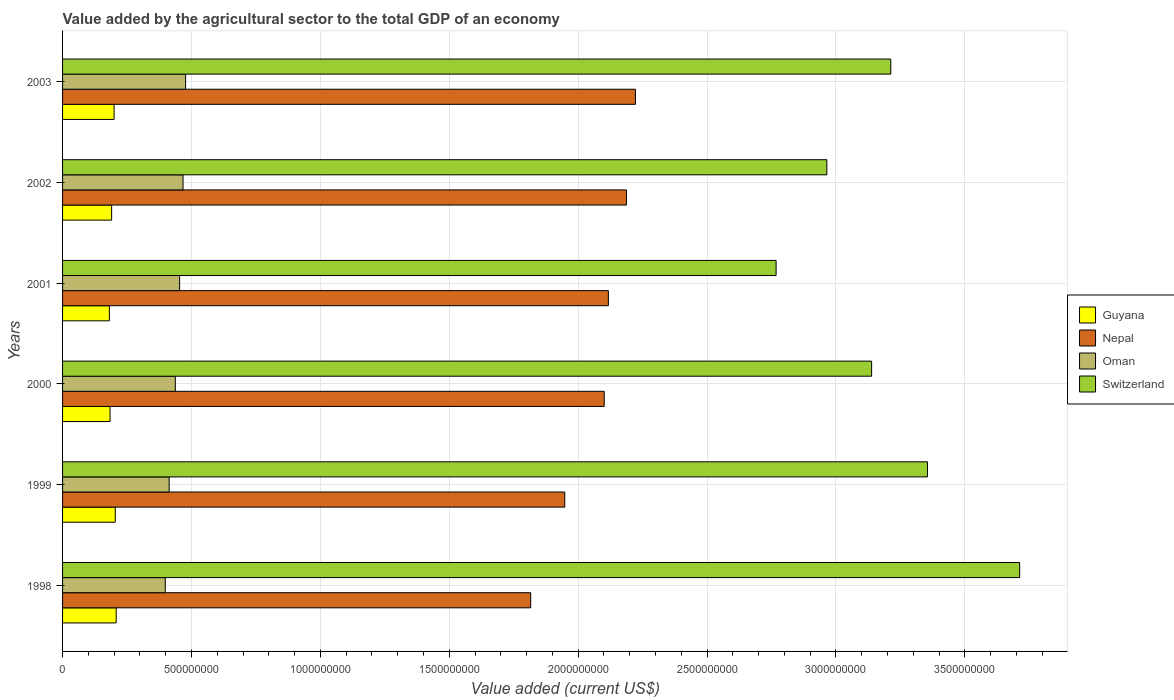How many groups of bars are there?
Keep it short and to the point. 6. Are the number of bars per tick equal to the number of legend labels?
Offer a terse response. Yes. How many bars are there on the 5th tick from the bottom?
Provide a short and direct response. 4. What is the label of the 3rd group of bars from the top?
Ensure brevity in your answer.  2001. In how many cases, is the number of bars for a given year not equal to the number of legend labels?
Provide a short and direct response. 0. What is the value added by the agricultural sector to the total GDP in Oman in 2003?
Your answer should be compact. 4.77e+08. Across all years, what is the maximum value added by the agricultural sector to the total GDP in Guyana?
Provide a short and direct response. 2.08e+08. Across all years, what is the minimum value added by the agricultural sector to the total GDP in Nepal?
Your response must be concise. 1.82e+09. In which year was the value added by the agricultural sector to the total GDP in Nepal maximum?
Your answer should be compact. 2003. In which year was the value added by the agricultural sector to the total GDP in Nepal minimum?
Offer a very short reply. 1998. What is the total value added by the agricultural sector to the total GDP in Nepal in the graph?
Provide a short and direct response. 1.24e+1. What is the difference between the value added by the agricultural sector to the total GDP in Guyana in 1998 and that in 2003?
Your response must be concise. 8.14e+06. What is the difference between the value added by the agricultural sector to the total GDP in Guyana in 2000 and the value added by the agricultural sector to the total GDP in Oman in 1998?
Your answer should be compact. -2.14e+08. What is the average value added by the agricultural sector to the total GDP in Oman per year?
Ensure brevity in your answer.  4.41e+08. In the year 2001, what is the difference between the value added by the agricultural sector to the total GDP in Guyana and value added by the agricultural sector to the total GDP in Switzerland?
Provide a succinct answer. -2.59e+09. In how many years, is the value added by the agricultural sector to the total GDP in Guyana greater than 500000000 US$?
Ensure brevity in your answer.  0. What is the ratio of the value added by the agricultural sector to the total GDP in Oman in 1998 to that in 2002?
Offer a very short reply. 0.85. Is the value added by the agricultural sector to the total GDP in Nepal in 1999 less than that in 2000?
Offer a terse response. Yes. Is the difference between the value added by the agricultural sector to the total GDP in Guyana in 1998 and 2000 greater than the difference between the value added by the agricultural sector to the total GDP in Switzerland in 1998 and 2000?
Your answer should be compact. No. What is the difference between the highest and the second highest value added by the agricultural sector to the total GDP in Guyana?
Offer a terse response. 3.48e+06. What is the difference between the highest and the lowest value added by the agricultural sector to the total GDP in Guyana?
Offer a very short reply. 2.65e+07. In how many years, is the value added by the agricultural sector to the total GDP in Oman greater than the average value added by the agricultural sector to the total GDP in Oman taken over all years?
Your response must be concise. 3. What does the 2nd bar from the top in 2001 represents?
Offer a very short reply. Oman. What does the 1st bar from the bottom in 1999 represents?
Give a very brief answer. Guyana. Is it the case that in every year, the sum of the value added by the agricultural sector to the total GDP in Nepal and value added by the agricultural sector to the total GDP in Guyana is greater than the value added by the agricultural sector to the total GDP in Switzerland?
Give a very brief answer. No. Are all the bars in the graph horizontal?
Your answer should be very brief. Yes. Are the values on the major ticks of X-axis written in scientific E-notation?
Your answer should be compact. No. How are the legend labels stacked?
Your answer should be compact. Vertical. What is the title of the graph?
Your response must be concise. Value added by the agricultural sector to the total GDP of an economy. Does "Sub-Saharan Africa (all income levels)" appear as one of the legend labels in the graph?
Make the answer very short. No. What is the label or title of the X-axis?
Make the answer very short. Value added (current US$). What is the label or title of the Y-axis?
Provide a succinct answer. Years. What is the Value added (current US$) of Guyana in 1998?
Make the answer very short. 2.08e+08. What is the Value added (current US$) of Nepal in 1998?
Your answer should be compact. 1.82e+09. What is the Value added (current US$) of Oman in 1998?
Your answer should be very brief. 3.98e+08. What is the Value added (current US$) in Switzerland in 1998?
Your answer should be compact. 3.71e+09. What is the Value added (current US$) of Guyana in 1999?
Provide a short and direct response. 2.05e+08. What is the Value added (current US$) in Nepal in 1999?
Your answer should be very brief. 1.95e+09. What is the Value added (current US$) of Oman in 1999?
Your answer should be very brief. 4.14e+08. What is the Value added (current US$) of Switzerland in 1999?
Provide a short and direct response. 3.36e+09. What is the Value added (current US$) in Guyana in 2000?
Your answer should be compact. 1.84e+08. What is the Value added (current US$) in Nepal in 2000?
Provide a succinct answer. 2.10e+09. What is the Value added (current US$) in Oman in 2000?
Ensure brevity in your answer.  4.37e+08. What is the Value added (current US$) in Switzerland in 2000?
Offer a very short reply. 3.14e+09. What is the Value added (current US$) of Guyana in 2001?
Make the answer very short. 1.82e+08. What is the Value added (current US$) of Nepal in 2001?
Your answer should be compact. 2.12e+09. What is the Value added (current US$) in Oman in 2001?
Offer a terse response. 4.54e+08. What is the Value added (current US$) in Switzerland in 2001?
Ensure brevity in your answer.  2.77e+09. What is the Value added (current US$) of Guyana in 2002?
Offer a very short reply. 1.90e+08. What is the Value added (current US$) in Nepal in 2002?
Give a very brief answer. 2.19e+09. What is the Value added (current US$) of Oman in 2002?
Provide a short and direct response. 4.67e+08. What is the Value added (current US$) of Switzerland in 2002?
Give a very brief answer. 2.96e+09. What is the Value added (current US$) of Guyana in 2003?
Make the answer very short. 2.00e+08. What is the Value added (current US$) in Nepal in 2003?
Offer a terse response. 2.22e+09. What is the Value added (current US$) of Oman in 2003?
Make the answer very short. 4.77e+08. What is the Value added (current US$) in Switzerland in 2003?
Provide a succinct answer. 3.21e+09. Across all years, what is the maximum Value added (current US$) in Guyana?
Provide a succinct answer. 2.08e+08. Across all years, what is the maximum Value added (current US$) in Nepal?
Make the answer very short. 2.22e+09. Across all years, what is the maximum Value added (current US$) in Oman?
Your answer should be very brief. 4.77e+08. Across all years, what is the maximum Value added (current US$) of Switzerland?
Keep it short and to the point. 3.71e+09. Across all years, what is the minimum Value added (current US$) of Guyana?
Ensure brevity in your answer.  1.82e+08. Across all years, what is the minimum Value added (current US$) in Nepal?
Provide a succinct answer. 1.82e+09. Across all years, what is the minimum Value added (current US$) of Oman?
Make the answer very short. 3.98e+08. Across all years, what is the minimum Value added (current US$) in Switzerland?
Provide a short and direct response. 2.77e+09. What is the total Value added (current US$) in Guyana in the graph?
Your answer should be very brief. 1.17e+09. What is the total Value added (current US$) of Nepal in the graph?
Your answer should be very brief. 1.24e+1. What is the total Value added (current US$) of Oman in the graph?
Offer a terse response. 2.65e+09. What is the total Value added (current US$) in Switzerland in the graph?
Your answer should be very brief. 1.92e+1. What is the difference between the Value added (current US$) in Guyana in 1998 and that in 1999?
Your response must be concise. 3.48e+06. What is the difference between the Value added (current US$) in Nepal in 1998 and that in 1999?
Give a very brief answer. -1.32e+08. What is the difference between the Value added (current US$) in Oman in 1998 and that in 1999?
Give a very brief answer. -1.51e+07. What is the difference between the Value added (current US$) in Switzerland in 1998 and that in 1999?
Provide a short and direct response. 3.58e+08. What is the difference between the Value added (current US$) in Guyana in 1998 and that in 2000?
Provide a succinct answer. 2.38e+07. What is the difference between the Value added (current US$) of Nepal in 1998 and that in 2000?
Your answer should be very brief. -2.85e+08. What is the difference between the Value added (current US$) of Oman in 1998 and that in 2000?
Give a very brief answer. -3.90e+07. What is the difference between the Value added (current US$) of Switzerland in 1998 and that in 2000?
Give a very brief answer. 5.74e+08. What is the difference between the Value added (current US$) of Guyana in 1998 and that in 2001?
Offer a very short reply. 2.65e+07. What is the difference between the Value added (current US$) in Nepal in 1998 and that in 2001?
Make the answer very short. -3.01e+08. What is the difference between the Value added (current US$) of Oman in 1998 and that in 2001?
Provide a succinct answer. -5.57e+07. What is the difference between the Value added (current US$) of Switzerland in 1998 and that in 2001?
Give a very brief answer. 9.45e+08. What is the difference between the Value added (current US$) of Guyana in 1998 and that in 2002?
Your response must be concise. 1.76e+07. What is the difference between the Value added (current US$) in Nepal in 1998 and that in 2002?
Make the answer very short. -3.72e+08. What is the difference between the Value added (current US$) of Oman in 1998 and that in 2002?
Your answer should be compact. -6.89e+07. What is the difference between the Value added (current US$) in Switzerland in 1998 and that in 2002?
Your answer should be very brief. 7.48e+08. What is the difference between the Value added (current US$) in Guyana in 1998 and that in 2003?
Keep it short and to the point. 8.14e+06. What is the difference between the Value added (current US$) in Nepal in 1998 and that in 2003?
Your answer should be compact. -4.06e+08. What is the difference between the Value added (current US$) in Oman in 1998 and that in 2003?
Keep it short and to the point. -7.88e+07. What is the difference between the Value added (current US$) of Switzerland in 1998 and that in 2003?
Your answer should be compact. 5.00e+08. What is the difference between the Value added (current US$) of Guyana in 1999 and that in 2000?
Provide a succinct answer. 2.03e+07. What is the difference between the Value added (current US$) of Nepal in 1999 and that in 2000?
Your answer should be compact. -1.53e+08. What is the difference between the Value added (current US$) in Oman in 1999 and that in 2000?
Your answer should be compact. -2.39e+07. What is the difference between the Value added (current US$) in Switzerland in 1999 and that in 2000?
Your answer should be compact. 2.17e+08. What is the difference between the Value added (current US$) in Guyana in 1999 and that in 2001?
Your answer should be compact. 2.30e+07. What is the difference between the Value added (current US$) of Nepal in 1999 and that in 2001?
Offer a very short reply. -1.69e+08. What is the difference between the Value added (current US$) in Oman in 1999 and that in 2001?
Your answer should be compact. -4.06e+07. What is the difference between the Value added (current US$) of Switzerland in 1999 and that in 2001?
Your answer should be compact. 5.87e+08. What is the difference between the Value added (current US$) of Guyana in 1999 and that in 2002?
Provide a succinct answer. 1.41e+07. What is the difference between the Value added (current US$) in Nepal in 1999 and that in 2002?
Your answer should be compact. -2.39e+08. What is the difference between the Value added (current US$) of Oman in 1999 and that in 2002?
Provide a short and direct response. -5.38e+07. What is the difference between the Value added (current US$) of Switzerland in 1999 and that in 2002?
Offer a very short reply. 3.90e+08. What is the difference between the Value added (current US$) of Guyana in 1999 and that in 2003?
Provide a succinct answer. 4.66e+06. What is the difference between the Value added (current US$) in Nepal in 1999 and that in 2003?
Provide a succinct answer. -2.74e+08. What is the difference between the Value added (current US$) of Oman in 1999 and that in 2003?
Provide a short and direct response. -6.37e+07. What is the difference between the Value added (current US$) in Switzerland in 1999 and that in 2003?
Your answer should be very brief. 1.42e+08. What is the difference between the Value added (current US$) of Guyana in 2000 and that in 2001?
Your response must be concise. 2.65e+06. What is the difference between the Value added (current US$) of Nepal in 2000 and that in 2001?
Give a very brief answer. -1.61e+07. What is the difference between the Value added (current US$) in Oman in 2000 and that in 2001?
Provide a short and direct response. -1.66e+07. What is the difference between the Value added (current US$) of Switzerland in 2000 and that in 2001?
Offer a very short reply. 3.71e+08. What is the difference between the Value added (current US$) of Guyana in 2000 and that in 2002?
Make the answer very short. -6.18e+06. What is the difference between the Value added (current US$) in Nepal in 2000 and that in 2002?
Give a very brief answer. -8.62e+07. What is the difference between the Value added (current US$) of Oman in 2000 and that in 2002?
Make the answer very short. -2.99e+07. What is the difference between the Value added (current US$) of Switzerland in 2000 and that in 2002?
Provide a succinct answer. 1.74e+08. What is the difference between the Value added (current US$) of Guyana in 2000 and that in 2003?
Offer a very short reply. -1.57e+07. What is the difference between the Value added (current US$) of Nepal in 2000 and that in 2003?
Give a very brief answer. -1.21e+08. What is the difference between the Value added (current US$) of Oman in 2000 and that in 2003?
Keep it short and to the point. -3.98e+07. What is the difference between the Value added (current US$) in Switzerland in 2000 and that in 2003?
Your response must be concise. -7.43e+07. What is the difference between the Value added (current US$) in Guyana in 2001 and that in 2002?
Your answer should be very brief. -8.84e+06. What is the difference between the Value added (current US$) in Nepal in 2001 and that in 2002?
Your answer should be compact. -7.01e+07. What is the difference between the Value added (current US$) in Oman in 2001 and that in 2002?
Your response must be concise. -1.33e+07. What is the difference between the Value added (current US$) in Switzerland in 2001 and that in 2002?
Make the answer very short. -1.97e+08. What is the difference between the Value added (current US$) of Guyana in 2001 and that in 2003?
Your answer should be compact. -1.83e+07. What is the difference between the Value added (current US$) of Nepal in 2001 and that in 2003?
Give a very brief answer. -1.05e+08. What is the difference between the Value added (current US$) in Oman in 2001 and that in 2003?
Provide a short and direct response. -2.31e+07. What is the difference between the Value added (current US$) of Switzerland in 2001 and that in 2003?
Provide a succinct answer. -4.45e+08. What is the difference between the Value added (current US$) of Guyana in 2002 and that in 2003?
Provide a succinct answer. -9.49e+06. What is the difference between the Value added (current US$) of Nepal in 2002 and that in 2003?
Your answer should be compact. -3.50e+07. What is the difference between the Value added (current US$) in Oman in 2002 and that in 2003?
Ensure brevity in your answer.  -9.88e+06. What is the difference between the Value added (current US$) in Switzerland in 2002 and that in 2003?
Offer a terse response. -2.48e+08. What is the difference between the Value added (current US$) in Guyana in 1998 and the Value added (current US$) in Nepal in 1999?
Your answer should be compact. -1.74e+09. What is the difference between the Value added (current US$) of Guyana in 1998 and the Value added (current US$) of Oman in 1999?
Keep it short and to the point. -2.06e+08. What is the difference between the Value added (current US$) in Guyana in 1998 and the Value added (current US$) in Switzerland in 1999?
Make the answer very short. -3.15e+09. What is the difference between the Value added (current US$) of Nepal in 1998 and the Value added (current US$) of Oman in 1999?
Ensure brevity in your answer.  1.40e+09. What is the difference between the Value added (current US$) in Nepal in 1998 and the Value added (current US$) in Switzerland in 1999?
Offer a very short reply. -1.54e+09. What is the difference between the Value added (current US$) of Oman in 1998 and the Value added (current US$) of Switzerland in 1999?
Provide a short and direct response. -2.96e+09. What is the difference between the Value added (current US$) in Guyana in 1998 and the Value added (current US$) in Nepal in 2000?
Give a very brief answer. -1.89e+09. What is the difference between the Value added (current US$) in Guyana in 1998 and the Value added (current US$) in Oman in 2000?
Provide a succinct answer. -2.29e+08. What is the difference between the Value added (current US$) of Guyana in 1998 and the Value added (current US$) of Switzerland in 2000?
Keep it short and to the point. -2.93e+09. What is the difference between the Value added (current US$) in Nepal in 1998 and the Value added (current US$) in Oman in 2000?
Keep it short and to the point. 1.38e+09. What is the difference between the Value added (current US$) in Nepal in 1998 and the Value added (current US$) in Switzerland in 2000?
Give a very brief answer. -1.32e+09. What is the difference between the Value added (current US$) in Oman in 1998 and the Value added (current US$) in Switzerland in 2000?
Give a very brief answer. -2.74e+09. What is the difference between the Value added (current US$) in Guyana in 1998 and the Value added (current US$) in Nepal in 2001?
Your response must be concise. -1.91e+09. What is the difference between the Value added (current US$) of Guyana in 1998 and the Value added (current US$) of Oman in 2001?
Provide a succinct answer. -2.46e+08. What is the difference between the Value added (current US$) in Guyana in 1998 and the Value added (current US$) in Switzerland in 2001?
Give a very brief answer. -2.56e+09. What is the difference between the Value added (current US$) in Nepal in 1998 and the Value added (current US$) in Oman in 2001?
Your response must be concise. 1.36e+09. What is the difference between the Value added (current US$) of Nepal in 1998 and the Value added (current US$) of Switzerland in 2001?
Keep it short and to the point. -9.52e+08. What is the difference between the Value added (current US$) in Oman in 1998 and the Value added (current US$) in Switzerland in 2001?
Offer a terse response. -2.37e+09. What is the difference between the Value added (current US$) of Guyana in 1998 and the Value added (current US$) of Nepal in 2002?
Make the answer very short. -1.98e+09. What is the difference between the Value added (current US$) in Guyana in 1998 and the Value added (current US$) in Oman in 2002?
Ensure brevity in your answer.  -2.59e+08. What is the difference between the Value added (current US$) of Guyana in 1998 and the Value added (current US$) of Switzerland in 2002?
Your response must be concise. -2.76e+09. What is the difference between the Value added (current US$) in Nepal in 1998 and the Value added (current US$) in Oman in 2002?
Your response must be concise. 1.35e+09. What is the difference between the Value added (current US$) of Nepal in 1998 and the Value added (current US$) of Switzerland in 2002?
Your response must be concise. -1.15e+09. What is the difference between the Value added (current US$) in Oman in 1998 and the Value added (current US$) in Switzerland in 2002?
Provide a succinct answer. -2.57e+09. What is the difference between the Value added (current US$) of Guyana in 1998 and the Value added (current US$) of Nepal in 2003?
Provide a short and direct response. -2.01e+09. What is the difference between the Value added (current US$) of Guyana in 1998 and the Value added (current US$) of Oman in 2003?
Make the answer very short. -2.69e+08. What is the difference between the Value added (current US$) in Guyana in 1998 and the Value added (current US$) in Switzerland in 2003?
Keep it short and to the point. -3.00e+09. What is the difference between the Value added (current US$) in Nepal in 1998 and the Value added (current US$) in Oman in 2003?
Your answer should be very brief. 1.34e+09. What is the difference between the Value added (current US$) in Nepal in 1998 and the Value added (current US$) in Switzerland in 2003?
Provide a succinct answer. -1.40e+09. What is the difference between the Value added (current US$) in Oman in 1998 and the Value added (current US$) in Switzerland in 2003?
Keep it short and to the point. -2.81e+09. What is the difference between the Value added (current US$) of Guyana in 1999 and the Value added (current US$) of Nepal in 2000?
Offer a terse response. -1.90e+09. What is the difference between the Value added (current US$) of Guyana in 1999 and the Value added (current US$) of Oman in 2000?
Your answer should be compact. -2.33e+08. What is the difference between the Value added (current US$) in Guyana in 1999 and the Value added (current US$) in Switzerland in 2000?
Give a very brief answer. -2.93e+09. What is the difference between the Value added (current US$) of Nepal in 1999 and the Value added (current US$) of Oman in 2000?
Give a very brief answer. 1.51e+09. What is the difference between the Value added (current US$) in Nepal in 1999 and the Value added (current US$) in Switzerland in 2000?
Keep it short and to the point. -1.19e+09. What is the difference between the Value added (current US$) in Oman in 1999 and the Value added (current US$) in Switzerland in 2000?
Offer a terse response. -2.73e+09. What is the difference between the Value added (current US$) of Guyana in 1999 and the Value added (current US$) of Nepal in 2001?
Provide a succinct answer. -1.91e+09. What is the difference between the Value added (current US$) of Guyana in 1999 and the Value added (current US$) of Oman in 2001?
Provide a succinct answer. -2.50e+08. What is the difference between the Value added (current US$) of Guyana in 1999 and the Value added (current US$) of Switzerland in 2001?
Make the answer very short. -2.56e+09. What is the difference between the Value added (current US$) of Nepal in 1999 and the Value added (current US$) of Oman in 2001?
Offer a terse response. 1.49e+09. What is the difference between the Value added (current US$) of Nepal in 1999 and the Value added (current US$) of Switzerland in 2001?
Your answer should be very brief. -8.20e+08. What is the difference between the Value added (current US$) of Oman in 1999 and the Value added (current US$) of Switzerland in 2001?
Offer a very short reply. -2.35e+09. What is the difference between the Value added (current US$) in Guyana in 1999 and the Value added (current US$) in Nepal in 2002?
Make the answer very short. -1.98e+09. What is the difference between the Value added (current US$) in Guyana in 1999 and the Value added (current US$) in Oman in 2002?
Your answer should be compact. -2.63e+08. What is the difference between the Value added (current US$) of Guyana in 1999 and the Value added (current US$) of Switzerland in 2002?
Provide a short and direct response. -2.76e+09. What is the difference between the Value added (current US$) in Nepal in 1999 and the Value added (current US$) in Oman in 2002?
Give a very brief answer. 1.48e+09. What is the difference between the Value added (current US$) of Nepal in 1999 and the Value added (current US$) of Switzerland in 2002?
Your answer should be compact. -1.02e+09. What is the difference between the Value added (current US$) in Oman in 1999 and the Value added (current US$) in Switzerland in 2002?
Make the answer very short. -2.55e+09. What is the difference between the Value added (current US$) of Guyana in 1999 and the Value added (current US$) of Nepal in 2003?
Offer a very short reply. -2.02e+09. What is the difference between the Value added (current US$) in Guyana in 1999 and the Value added (current US$) in Oman in 2003?
Make the answer very short. -2.73e+08. What is the difference between the Value added (current US$) in Guyana in 1999 and the Value added (current US$) in Switzerland in 2003?
Make the answer very short. -3.01e+09. What is the difference between the Value added (current US$) of Nepal in 1999 and the Value added (current US$) of Oman in 2003?
Ensure brevity in your answer.  1.47e+09. What is the difference between the Value added (current US$) in Nepal in 1999 and the Value added (current US$) in Switzerland in 2003?
Offer a very short reply. -1.26e+09. What is the difference between the Value added (current US$) of Oman in 1999 and the Value added (current US$) of Switzerland in 2003?
Give a very brief answer. -2.80e+09. What is the difference between the Value added (current US$) in Guyana in 2000 and the Value added (current US$) in Nepal in 2001?
Make the answer very short. -1.93e+09. What is the difference between the Value added (current US$) in Guyana in 2000 and the Value added (current US$) in Oman in 2001?
Offer a very short reply. -2.70e+08. What is the difference between the Value added (current US$) in Guyana in 2000 and the Value added (current US$) in Switzerland in 2001?
Keep it short and to the point. -2.58e+09. What is the difference between the Value added (current US$) in Nepal in 2000 and the Value added (current US$) in Oman in 2001?
Keep it short and to the point. 1.65e+09. What is the difference between the Value added (current US$) in Nepal in 2000 and the Value added (current US$) in Switzerland in 2001?
Offer a very short reply. -6.67e+08. What is the difference between the Value added (current US$) of Oman in 2000 and the Value added (current US$) of Switzerland in 2001?
Keep it short and to the point. -2.33e+09. What is the difference between the Value added (current US$) in Guyana in 2000 and the Value added (current US$) in Nepal in 2002?
Your answer should be very brief. -2.00e+09. What is the difference between the Value added (current US$) in Guyana in 2000 and the Value added (current US$) in Oman in 2002?
Provide a succinct answer. -2.83e+08. What is the difference between the Value added (current US$) in Guyana in 2000 and the Value added (current US$) in Switzerland in 2002?
Provide a succinct answer. -2.78e+09. What is the difference between the Value added (current US$) in Nepal in 2000 and the Value added (current US$) in Oman in 2002?
Ensure brevity in your answer.  1.63e+09. What is the difference between the Value added (current US$) of Nepal in 2000 and the Value added (current US$) of Switzerland in 2002?
Ensure brevity in your answer.  -8.64e+08. What is the difference between the Value added (current US$) of Oman in 2000 and the Value added (current US$) of Switzerland in 2002?
Offer a very short reply. -2.53e+09. What is the difference between the Value added (current US$) of Guyana in 2000 and the Value added (current US$) of Nepal in 2003?
Offer a terse response. -2.04e+09. What is the difference between the Value added (current US$) of Guyana in 2000 and the Value added (current US$) of Oman in 2003?
Your answer should be compact. -2.93e+08. What is the difference between the Value added (current US$) of Guyana in 2000 and the Value added (current US$) of Switzerland in 2003?
Offer a terse response. -3.03e+09. What is the difference between the Value added (current US$) in Nepal in 2000 and the Value added (current US$) in Oman in 2003?
Offer a very short reply. 1.62e+09. What is the difference between the Value added (current US$) of Nepal in 2000 and the Value added (current US$) of Switzerland in 2003?
Your answer should be compact. -1.11e+09. What is the difference between the Value added (current US$) of Oman in 2000 and the Value added (current US$) of Switzerland in 2003?
Keep it short and to the point. -2.78e+09. What is the difference between the Value added (current US$) in Guyana in 2001 and the Value added (current US$) in Nepal in 2002?
Ensure brevity in your answer.  -2.01e+09. What is the difference between the Value added (current US$) of Guyana in 2001 and the Value added (current US$) of Oman in 2002?
Ensure brevity in your answer.  -2.86e+08. What is the difference between the Value added (current US$) of Guyana in 2001 and the Value added (current US$) of Switzerland in 2002?
Keep it short and to the point. -2.78e+09. What is the difference between the Value added (current US$) in Nepal in 2001 and the Value added (current US$) in Oman in 2002?
Your response must be concise. 1.65e+09. What is the difference between the Value added (current US$) in Nepal in 2001 and the Value added (current US$) in Switzerland in 2002?
Give a very brief answer. -8.48e+08. What is the difference between the Value added (current US$) of Oman in 2001 and the Value added (current US$) of Switzerland in 2002?
Ensure brevity in your answer.  -2.51e+09. What is the difference between the Value added (current US$) in Guyana in 2001 and the Value added (current US$) in Nepal in 2003?
Give a very brief answer. -2.04e+09. What is the difference between the Value added (current US$) in Guyana in 2001 and the Value added (current US$) in Oman in 2003?
Offer a very short reply. -2.96e+08. What is the difference between the Value added (current US$) in Guyana in 2001 and the Value added (current US$) in Switzerland in 2003?
Provide a succinct answer. -3.03e+09. What is the difference between the Value added (current US$) in Nepal in 2001 and the Value added (current US$) in Oman in 2003?
Offer a very short reply. 1.64e+09. What is the difference between the Value added (current US$) of Nepal in 2001 and the Value added (current US$) of Switzerland in 2003?
Your answer should be very brief. -1.10e+09. What is the difference between the Value added (current US$) of Oman in 2001 and the Value added (current US$) of Switzerland in 2003?
Provide a short and direct response. -2.76e+09. What is the difference between the Value added (current US$) in Guyana in 2002 and the Value added (current US$) in Nepal in 2003?
Make the answer very short. -2.03e+09. What is the difference between the Value added (current US$) in Guyana in 2002 and the Value added (current US$) in Oman in 2003?
Make the answer very short. -2.87e+08. What is the difference between the Value added (current US$) of Guyana in 2002 and the Value added (current US$) of Switzerland in 2003?
Give a very brief answer. -3.02e+09. What is the difference between the Value added (current US$) in Nepal in 2002 and the Value added (current US$) in Oman in 2003?
Your response must be concise. 1.71e+09. What is the difference between the Value added (current US$) of Nepal in 2002 and the Value added (current US$) of Switzerland in 2003?
Give a very brief answer. -1.03e+09. What is the difference between the Value added (current US$) in Oman in 2002 and the Value added (current US$) in Switzerland in 2003?
Your answer should be very brief. -2.75e+09. What is the average Value added (current US$) of Guyana per year?
Your response must be concise. 1.95e+08. What is the average Value added (current US$) in Nepal per year?
Provide a succinct answer. 2.07e+09. What is the average Value added (current US$) of Oman per year?
Provide a short and direct response. 4.41e+08. What is the average Value added (current US$) in Switzerland per year?
Provide a succinct answer. 3.19e+09. In the year 1998, what is the difference between the Value added (current US$) in Guyana and Value added (current US$) in Nepal?
Your answer should be very brief. -1.61e+09. In the year 1998, what is the difference between the Value added (current US$) of Guyana and Value added (current US$) of Oman?
Give a very brief answer. -1.90e+08. In the year 1998, what is the difference between the Value added (current US$) in Guyana and Value added (current US$) in Switzerland?
Your answer should be compact. -3.50e+09. In the year 1998, what is the difference between the Value added (current US$) in Nepal and Value added (current US$) in Oman?
Your answer should be compact. 1.42e+09. In the year 1998, what is the difference between the Value added (current US$) in Nepal and Value added (current US$) in Switzerland?
Keep it short and to the point. -1.90e+09. In the year 1998, what is the difference between the Value added (current US$) of Oman and Value added (current US$) of Switzerland?
Give a very brief answer. -3.31e+09. In the year 1999, what is the difference between the Value added (current US$) in Guyana and Value added (current US$) in Nepal?
Give a very brief answer. -1.74e+09. In the year 1999, what is the difference between the Value added (current US$) of Guyana and Value added (current US$) of Oman?
Your response must be concise. -2.09e+08. In the year 1999, what is the difference between the Value added (current US$) in Guyana and Value added (current US$) in Switzerland?
Keep it short and to the point. -3.15e+09. In the year 1999, what is the difference between the Value added (current US$) in Nepal and Value added (current US$) in Oman?
Your answer should be compact. 1.53e+09. In the year 1999, what is the difference between the Value added (current US$) in Nepal and Value added (current US$) in Switzerland?
Your answer should be very brief. -1.41e+09. In the year 1999, what is the difference between the Value added (current US$) of Oman and Value added (current US$) of Switzerland?
Your answer should be compact. -2.94e+09. In the year 2000, what is the difference between the Value added (current US$) of Guyana and Value added (current US$) of Nepal?
Your answer should be compact. -1.92e+09. In the year 2000, what is the difference between the Value added (current US$) of Guyana and Value added (current US$) of Oman?
Make the answer very short. -2.53e+08. In the year 2000, what is the difference between the Value added (current US$) of Guyana and Value added (current US$) of Switzerland?
Offer a terse response. -2.95e+09. In the year 2000, what is the difference between the Value added (current US$) in Nepal and Value added (current US$) in Oman?
Offer a terse response. 1.66e+09. In the year 2000, what is the difference between the Value added (current US$) of Nepal and Value added (current US$) of Switzerland?
Provide a succinct answer. -1.04e+09. In the year 2000, what is the difference between the Value added (current US$) of Oman and Value added (current US$) of Switzerland?
Keep it short and to the point. -2.70e+09. In the year 2001, what is the difference between the Value added (current US$) in Guyana and Value added (current US$) in Nepal?
Give a very brief answer. -1.94e+09. In the year 2001, what is the difference between the Value added (current US$) of Guyana and Value added (current US$) of Oman?
Provide a succinct answer. -2.73e+08. In the year 2001, what is the difference between the Value added (current US$) of Guyana and Value added (current US$) of Switzerland?
Offer a very short reply. -2.59e+09. In the year 2001, what is the difference between the Value added (current US$) in Nepal and Value added (current US$) in Oman?
Make the answer very short. 1.66e+09. In the year 2001, what is the difference between the Value added (current US$) of Nepal and Value added (current US$) of Switzerland?
Give a very brief answer. -6.51e+08. In the year 2001, what is the difference between the Value added (current US$) of Oman and Value added (current US$) of Switzerland?
Ensure brevity in your answer.  -2.31e+09. In the year 2002, what is the difference between the Value added (current US$) of Guyana and Value added (current US$) of Nepal?
Your answer should be compact. -2.00e+09. In the year 2002, what is the difference between the Value added (current US$) in Guyana and Value added (current US$) in Oman?
Ensure brevity in your answer.  -2.77e+08. In the year 2002, what is the difference between the Value added (current US$) of Guyana and Value added (current US$) of Switzerland?
Make the answer very short. -2.77e+09. In the year 2002, what is the difference between the Value added (current US$) in Nepal and Value added (current US$) in Oman?
Make the answer very short. 1.72e+09. In the year 2002, what is the difference between the Value added (current US$) of Nepal and Value added (current US$) of Switzerland?
Your response must be concise. -7.77e+08. In the year 2002, what is the difference between the Value added (current US$) of Oman and Value added (current US$) of Switzerland?
Your answer should be compact. -2.50e+09. In the year 2003, what is the difference between the Value added (current US$) of Guyana and Value added (current US$) of Nepal?
Keep it short and to the point. -2.02e+09. In the year 2003, what is the difference between the Value added (current US$) in Guyana and Value added (current US$) in Oman?
Provide a succinct answer. -2.77e+08. In the year 2003, what is the difference between the Value added (current US$) in Guyana and Value added (current US$) in Switzerland?
Offer a terse response. -3.01e+09. In the year 2003, what is the difference between the Value added (current US$) of Nepal and Value added (current US$) of Oman?
Your response must be concise. 1.75e+09. In the year 2003, what is the difference between the Value added (current US$) of Nepal and Value added (current US$) of Switzerland?
Your answer should be compact. -9.90e+08. In the year 2003, what is the difference between the Value added (current US$) in Oman and Value added (current US$) in Switzerland?
Make the answer very short. -2.74e+09. What is the ratio of the Value added (current US$) in Guyana in 1998 to that in 1999?
Make the answer very short. 1.02. What is the ratio of the Value added (current US$) of Nepal in 1998 to that in 1999?
Your answer should be compact. 0.93. What is the ratio of the Value added (current US$) in Oman in 1998 to that in 1999?
Your answer should be compact. 0.96. What is the ratio of the Value added (current US$) of Switzerland in 1998 to that in 1999?
Ensure brevity in your answer.  1.11. What is the ratio of the Value added (current US$) of Guyana in 1998 to that in 2000?
Provide a succinct answer. 1.13. What is the ratio of the Value added (current US$) of Nepal in 1998 to that in 2000?
Give a very brief answer. 0.86. What is the ratio of the Value added (current US$) in Oman in 1998 to that in 2000?
Make the answer very short. 0.91. What is the ratio of the Value added (current US$) of Switzerland in 1998 to that in 2000?
Your response must be concise. 1.18. What is the ratio of the Value added (current US$) of Guyana in 1998 to that in 2001?
Provide a succinct answer. 1.15. What is the ratio of the Value added (current US$) in Nepal in 1998 to that in 2001?
Make the answer very short. 0.86. What is the ratio of the Value added (current US$) of Oman in 1998 to that in 2001?
Provide a succinct answer. 0.88. What is the ratio of the Value added (current US$) in Switzerland in 1998 to that in 2001?
Your response must be concise. 1.34. What is the ratio of the Value added (current US$) in Guyana in 1998 to that in 2002?
Your answer should be very brief. 1.09. What is the ratio of the Value added (current US$) in Nepal in 1998 to that in 2002?
Offer a terse response. 0.83. What is the ratio of the Value added (current US$) in Oman in 1998 to that in 2002?
Offer a very short reply. 0.85. What is the ratio of the Value added (current US$) in Switzerland in 1998 to that in 2002?
Keep it short and to the point. 1.25. What is the ratio of the Value added (current US$) of Guyana in 1998 to that in 2003?
Keep it short and to the point. 1.04. What is the ratio of the Value added (current US$) in Nepal in 1998 to that in 2003?
Give a very brief answer. 0.82. What is the ratio of the Value added (current US$) in Oman in 1998 to that in 2003?
Your response must be concise. 0.83. What is the ratio of the Value added (current US$) in Switzerland in 1998 to that in 2003?
Keep it short and to the point. 1.16. What is the ratio of the Value added (current US$) of Guyana in 1999 to that in 2000?
Your answer should be very brief. 1.11. What is the ratio of the Value added (current US$) in Nepal in 1999 to that in 2000?
Ensure brevity in your answer.  0.93. What is the ratio of the Value added (current US$) of Oman in 1999 to that in 2000?
Offer a terse response. 0.95. What is the ratio of the Value added (current US$) of Switzerland in 1999 to that in 2000?
Your response must be concise. 1.07. What is the ratio of the Value added (current US$) in Guyana in 1999 to that in 2001?
Your response must be concise. 1.13. What is the ratio of the Value added (current US$) in Nepal in 1999 to that in 2001?
Provide a succinct answer. 0.92. What is the ratio of the Value added (current US$) of Oman in 1999 to that in 2001?
Offer a very short reply. 0.91. What is the ratio of the Value added (current US$) in Switzerland in 1999 to that in 2001?
Provide a short and direct response. 1.21. What is the ratio of the Value added (current US$) of Guyana in 1999 to that in 2002?
Provide a short and direct response. 1.07. What is the ratio of the Value added (current US$) in Nepal in 1999 to that in 2002?
Offer a very short reply. 0.89. What is the ratio of the Value added (current US$) in Oman in 1999 to that in 2002?
Your response must be concise. 0.88. What is the ratio of the Value added (current US$) in Switzerland in 1999 to that in 2002?
Your response must be concise. 1.13. What is the ratio of the Value added (current US$) in Guyana in 1999 to that in 2003?
Give a very brief answer. 1.02. What is the ratio of the Value added (current US$) of Nepal in 1999 to that in 2003?
Your answer should be compact. 0.88. What is the ratio of the Value added (current US$) in Oman in 1999 to that in 2003?
Offer a terse response. 0.87. What is the ratio of the Value added (current US$) in Switzerland in 1999 to that in 2003?
Ensure brevity in your answer.  1.04. What is the ratio of the Value added (current US$) of Guyana in 2000 to that in 2001?
Offer a very short reply. 1.01. What is the ratio of the Value added (current US$) of Oman in 2000 to that in 2001?
Your answer should be very brief. 0.96. What is the ratio of the Value added (current US$) in Switzerland in 2000 to that in 2001?
Your response must be concise. 1.13. What is the ratio of the Value added (current US$) of Guyana in 2000 to that in 2002?
Your response must be concise. 0.97. What is the ratio of the Value added (current US$) in Nepal in 2000 to that in 2002?
Provide a succinct answer. 0.96. What is the ratio of the Value added (current US$) of Oman in 2000 to that in 2002?
Offer a very short reply. 0.94. What is the ratio of the Value added (current US$) in Switzerland in 2000 to that in 2002?
Your answer should be compact. 1.06. What is the ratio of the Value added (current US$) of Guyana in 2000 to that in 2003?
Your response must be concise. 0.92. What is the ratio of the Value added (current US$) of Nepal in 2000 to that in 2003?
Provide a succinct answer. 0.95. What is the ratio of the Value added (current US$) in Oman in 2000 to that in 2003?
Your answer should be very brief. 0.92. What is the ratio of the Value added (current US$) in Switzerland in 2000 to that in 2003?
Offer a terse response. 0.98. What is the ratio of the Value added (current US$) of Guyana in 2001 to that in 2002?
Make the answer very short. 0.95. What is the ratio of the Value added (current US$) in Nepal in 2001 to that in 2002?
Your answer should be compact. 0.97. What is the ratio of the Value added (current US$) in Oman in 2001 to that in 2002?
Provide a succinct answer. 0.97. What is the ratio of the Value added (current US$) in Switzerland in 2001 to that in 2002?
Give a very brief answer. 0.93. What is the ratio of the Value added (current US$) of Guyana in 2001 to that in 2003?
Offer a terse response. 0.91. What is the ratio of the Value added (current US$) of Nepal in 2001 to that in 2003?
Provide a short and direct response. 0.95. What is the ratio of the Value added (current US$) in Oman in 2001 to that in 2003?
Keep it short and to the point. 0.95. What is the ratio of the Value added (current US$) of Switzerland in 2001 to that in 2003?
Your answer should be very brief. 0.86. What is the ratio of the Value added (current US$) in Guyana in 2002 to that in 2003?
Keep it short and to the point. 0.95. What is the ratio of the Value added (current US$) of Nepal in 2002 to that in 2003?
Provide a short and direct response. 0.98. What is the ratio of the Value added (current US$) in Oman in 2002 to that in 2003?
Provide a succinct answer. 0.98. What is the ratio of the Value added (current US$) of Switzerland in 2002 to that in 2003?
Your answer should be very brief. 0.92. What is the difference between the highest and the second highest Value added (current US$) in Guyana?
Provide a short and direct response. 3.48e+06. What is the difference between the highest and the second highest Value added (current US$) in Nepal?
Make the answer very short. 3.50e+07. What is the difference between the highest and the second highest Value added (current US$) of Oman?
Offer a very short reply. 9.88e+06. What is the difference between the highest and the second highest Value added (current US$) of Switzerland?
Provide a succinct answer. 3.58e+08. What is the difference between the highest and the lowest Value added (current US$) of Guyana?
Make the answer very short. 2.65e+07. What is the difference between the highest and the lowest Value added (current US$) in Nepal?
Your answer should be compact. 4.06e+08. What is the difference between the highest and the lowest Value added (current US$) in Oman?
Offer a very short reply. 7.88e+07. What is the difference between the highest and the lowest Value added (current US$) in Switzerland?
Offer a terse response. 9.45e+08. 